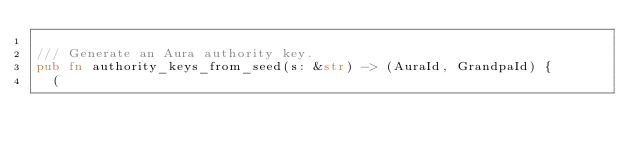Convert code to text. <code><loc_0><loc_0><loc_500><loc_500><_Rust_>
/// Generate an Aura authority key.
pub fn authority_keys_from_seed(s: &str) -> (AuraId, GrandpaId) {
	(</code> 